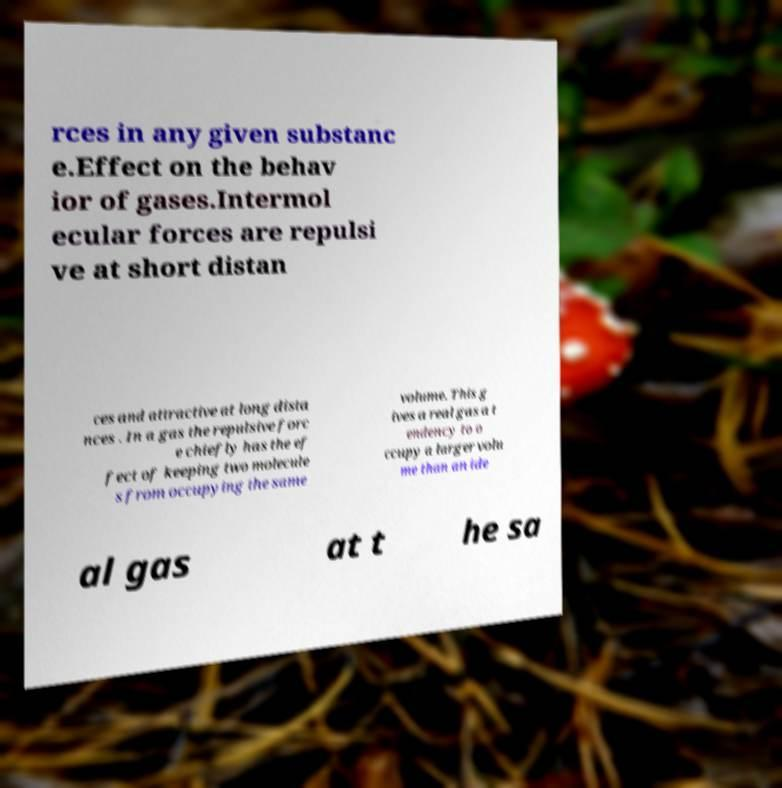There's text embedded in this image that I need extracted. Can you transcribe it verbatim? rces in any given substanc e.Effect on the behav ior of gases.Intermol ecular forces are repulsi ve at short distan ces and attractive at long dista nces . In a gas the repulsive forc e chiefly has the ef fect of keeping two molecule s from occupying the same volume. This g ives a real gas a t endency to o ccupy a larger volu me than an ide al gas at t he sa 